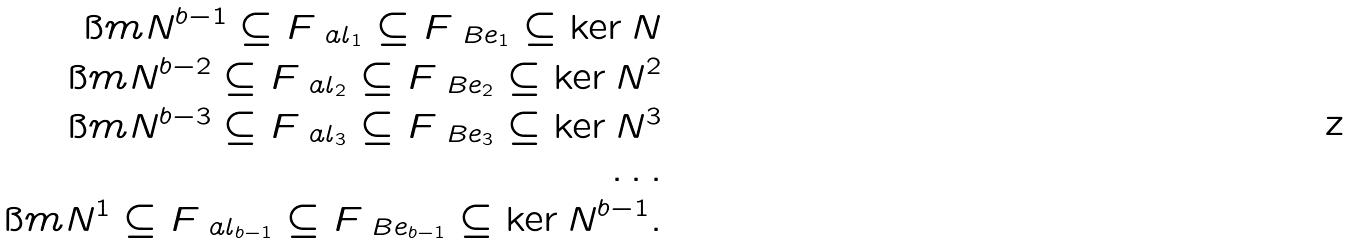Convert formula to latex. <formula><loc_0><loc_0><loc_500><loc_500>\i m N ^ { b - 1 } \subseteq F _ { \ a l _ { 1 } } \subseteq F _ { \ B e _ { 1 } } \subseteq \ker N \\ \i m N ^ { b - 2 } \subseteq F _ { \ a l _ { 2 } } \subseteq F _ { \ B e _ { 2 } } \subseteq \ker N ^ { 2 } \\ \i m N ^ { b - 3 } \subseteq F _ { \ a l _ { 3 } } \subseteq F _ { \ B e _ { 3 } } \subseteq \ker N ^ { 3 } \\ \dots \\ \i m N ^ { 1 } \subseteq F _ { \ a l _ { b - 1 } } \subseteq F _ { \ B e _ { b - 1 } } \subseteq \ker N ^ { b - 1 } .</formula> 